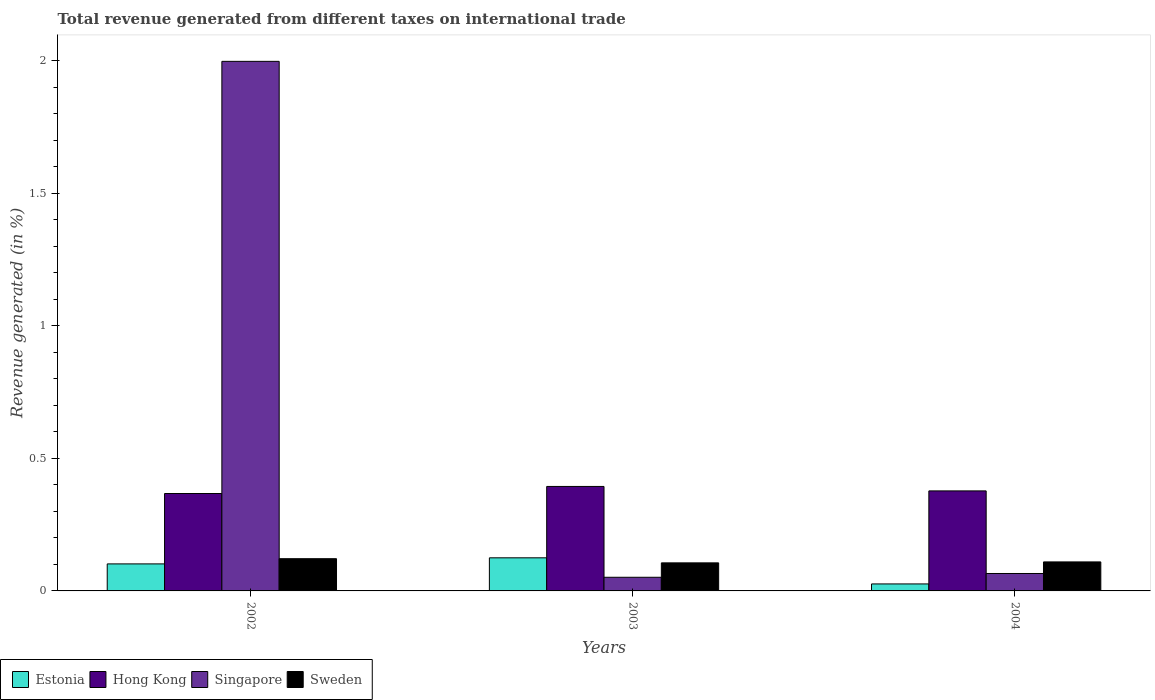How many different coloured bars are there?
Your answer should be compact. 4. How many groups of bars are there?
Your answer should be very brief. 3. Are the number of bars per tick equal to the number of legend labels?
Make the answer very short. Yes. Are the number of bars on each tick of the X-axis equal?
Ensure brevity in your answer.  Yes. How many bars are there on the 2nd tick from the left?
Your response must be concise. 4. What is the label of the 1st group of bars from the left?
Give a very brief answer. 2002. What is the total revenue generated in Singapore in 2004?
Keep it short and to the point. 0.07. Across all years, what is the maximum total revenue generated in Hong Kong?
Keep it short and to the point. 0.39. Across all years, what is the minimum total revenue generated in Singapore?
Make the answer very short. 0.05. In which year was the total revenue generated in Hong Kong maximum?
Your answer should be very brief. 2003. In which year was the total revenue generated in Hong Kong minimum?
Your answer should be very brief. 2002. What is the total total revenue generated in Sweden in the graph?
Offer a terse response. 0.34. What is the difference between the total revenue generated in Hong Kong in 2003 and that in 2004?
Provide a short and direct response. 0.02. What is the difference between the total revenue generated in Sweden in 2002 and the total revenue generated in Estonia in 2004?
Give a very brief answer. 0.1. What is the average total revenue generated in Singapore per year?
Your answer should be very brief. 0.7. In the year 2002, what is the difference between the total revenue generated in Estonia and total revenue generated in Singapore?
Your answer should be very brief. -1.9. In how many years, is the total revenue generated in Hong Kong greater than 1.6 %?
Keep it short and to the point. 0. What is the ratio of the total revenue generated in Estonia in 2002 to that in 2004?
Your response must be concise. 3.87. Is the total revenue generated in Singapore in 2003 less than that in 2004?
Give a very brief answer. Yes. What is the difference between the highest and the second highest total revenue generated in Estonia?
Provide a short and direct response. 0.02. What is the difference between the highest and the lowest total revenue generated in Estonia?
Offer a terse response. 0.1. In how many years, is the total revenue generated in Estonia greater than the average total revenue generated in Estonia taken over all years?
Give a very brief answer. 2. What does the 2nd bar from the left in 2003 represents?
Offer a very short reply. Hong Kong. Is it the case that in every year, the sum of the total revenue generated in Estonia and total revenue generated in Singapore is greater than the total revenue generated in Sweden?
Your response must be concise. No. What is the difference between two consecutive major ticks on the Y-axis?
Offer a very short reply. 0.5. Are the values on the major ticks of Y-axis written in scientific E-notation?
Keep it short and to the point. No. What is the title of the graph?
Keep it short and to the point. Total revenue generated from different taxes on international trade. What is the label or title of the Y-axis?
Offer a very short reply. Revenue generated (in %). What is the Revenue generated (in %) of Estonia in 2002?
Make the answer very short. 0.1. What is the Revenue generated (in %) of Hong Kong in 2002?
Make the answer very short. 0.37. What is the Revenue generated (in %) in Singapore in 2002?
Offer a terse response. 2. What is the Revenue generated (in %) of Sweden in 2002?
Your answer should be compact. 0.12. What is the Revenue generated (in %) in Estonia in 2003?
Offer a very short reply. 0.12. What is the Revenue generated (in %) in Hong Kong in 2003?
Keep it short and to the point. 0.39. What is the Revenue generated (in %) in Singapore in 2003?
Offer a very short reply. 0.05. What is the Revenue generated (in %) of Sweden in 2003?
Keep it short and to the point. 0.11. What is the Revenue generated (in %) in Estonia in 2004?
Provide a succinct answer. 0.03. What is the Revenue generated (in %) of Hong Kong in 2004?
Your answer should be very brief. 0.38. What is the Revenue generated (in %) in Singapore in 2004?
Your answer should be compact. 0.07. What is the Revenue generated (in %) of Sweden in 2004?
Give a very brief answer. 0.11. Across all years, what is the maximum Revenue generated (in %) in Estonia?
Keep it short and to the point. 0.12. Across all years, what is the maximum Revenue generated (in %) of Hong Kong?
Your response must be concise. 0.39. Across all years, what is the maximum Revenue generated (in %) of Singapore?
Provide a succinct answer. 2. Across all years, what is the maximum Revenue generated (in %) in Sweden?
Provide a short and direct response. 0.12. Across all years, what is the minimum Revenue generated (in %) of Estonia?
Your answer should be very brief. 0.03. Across all years, what is the minimum Revenue generated (in %) of Hong Kong?
Your response must be concise. 0.37. Across all years, what is the minimum Revenue generated (in %) in Singapore?
Give a very brief answer. 0.05. Across all years, what is the minimum Revenue generated (in %) of Sweden?
Provide a short and direct response. 0.11. What is the total Revenue generated (in %) in Estonia in the graph?
Your response must be concise. 0.25. What is the total Revenue generated (in %) of Hong Kong in the graph?
Your answer should be very brief. 1.14. What is the total Revenue generated (in %) of Singapore in the graph?
Offer a terse response. 2.11. What is the total Revenue generated (in %) in Sweden in the graph?
Provide a short and direct response. 0.34. What is the difference between the Revenue generated (in %) in Estonia in 2002 and that in 2003?
Give a very brief answer. -0.02. What is the difference between the Revenue generated (in %) in Hong Kong in 2002 and that in 2003?
Your answer should be compact. -0.03. What is the difference between the Revenue generated (in %) in Singapore in 2002 and that in 2003?
Your answer should be compact. 1.95. What is the difference between the Revenue generated (in %) of Sweden in 2002 and that in 2003?
Provide a succinct answer. 0.02. What is the difference between the Revenue generated (in %) of Estonia in 2002 and that in 2004?
Provide a succinct answer. 0.08. What is the difference between the Revenue generated (in %) of Hong Kong in 2002 and that in 2004?
Your answer should be compact. -0.01. What is the difference between the Revenue generated (in %) of Singapore in 2002 and that in 2004?
Offer a terse response. 1.93. What is the difference between the Revenue generated (in %) of Sweden in 2002 and that in 2004?
Give a very brief answer. 0.01. What is the difference between the Revenue generated (in %) of Estonia in 2003 and that in 2004?
Provide a short and direct response. 0.1. What is the difference between the Revenue generated (in %) in Hong Kong in 2003 and that in 2004?
Keep it short and to the point. 0.02. What is the difference between the Revenue generated (in %) of Singapore in 2003 and that in 2004?
Provide a succinct answer. -0.01. What is the difference between the Revenue generated (in %) of Sweden in 2003 and that in 2004?
Give a very brief answer. -0. What is the difference between the Revenue generated (in %) in Estonia in 2002 and the Revenue generated (in %) in Hong Kong in 2003?
Your response must be concise. -0.29. What is the difference between the Revenue generated (in %) in Estonia in 2002 and the Revenue generated (in %) in Singapore in 2003?
Provide a succinct answer. 0.05. What is the difference between the Revenue generated (in %) in Estonia in 2002 and the Revenue generated (in %) in Sweden in 2003?
Provide a short and direct response. -0. What is the difference between the Revenue generated (in %) in Hong Kong in 2002 and the Revenue generated (in %) in Singapore in 2003?
Your answer should be compact. 0.32. What is the difference between the Revenue generated (in %) of Hong Kong in 2002 and the Revenue generated (in %) of Sweden in 2003?
Ensure brevity in your answer.  0.26. What is the difference between the Revenue generated (in %) of Singapore in 2002 and the Revenue generated (in %) of Sweden in 2003?
Offer a very short reply. 1.89. What is the difference between the Revenue generated (in %) of Estonia in 2002 and the Revenue generated (in %) of Hong Kong in 2004?
Offer a terse response. -0.28. What is the difference between the Revenue generated (in %) in Estonia in 2002 and the Revenue generated (in %) in Singapore in 2004?
Provide a short and direct response. 0.04. What is the difference between the Revenue generated (in %) of Estonia in 2002 and the Revenue generated (in %) of Sweden in 2004?
Make the answer very short. -0.01. What is the difference between the Revenue generated (in %) of Hong Kong in 2002 and the Revenue generated (in %) of Singapore in 2004?
Provide a short and direct response. 0.3. What is the difference between the Revenue generated (in %) of Hong Kong in 2002 and the Revenue generated (in %) of Sweden in 2004?
Ensure brevity in your answer.  0.26. What is the difference between the Revenue generated (in %) in Singapore in 2002 and the Revenue generated (in %) in Sweden in 2004?
Keep it short and to the point. 1.89. What is the difference between the Revenue generated (in %) of Estonia in 2003 and the Revenue generated (in %) of Hong Kong in 2004?
Provide a succinct answer. -0.25. What is the difference between the Revenue generated (in %) in Estonia in 2003 and the Revenue generated (in %) in Singapore in 2004?
Your answer should be very brief. 0.06. What is the difference between the Revenue generated (in %) in Estonia in 2003 and the Revenue generated (in %) in Sweden in 2004?
Offer a very short reply. 0.02. What is the difference between the Revenue generated (in %) in Hong Kong in 2003 and the Revenue generated (in %) in Singapore in 2004?
Keep it short and to the point. 0.33. What is the difference between the Revenue generated (in %) in Hong Kong in 2003 and the Revenue generated (in %) in Sweden in 2004?
Offer a terse response. 0.28. What is the difference between the Revenue generated (in %) in Singapore in 2003 and the Revenue generated (in %) in Sweden in 2004?
Ensure brevity in your answer.  -0.06. What is the average Revenue generated (in %) in Estonia per year?
Provide a succinct answer. 0.08. What is the average Revenue generated (in %) in Hong Kong per year?
Ensure brevity in your answer.  0.38. What is the average Revenue generated (in %) of Singapore per year?
Offer a very short reply. 0.7. What is the average Revenue generated (in %) of Sweden per year?
Provide a succinct answer. 0.11. In the year 2002, what is the difference between the Revenue generated (in %) in Estonia and Revenue generated (in %) in Hong Kong?
Your response must be concise. -0.27. In the year 2002, what is the difference between the Revenue generated (in %) of Estonia and Revenue generated (in %) of Singapore?
Provide a short and direct response. -1.9. In the year 2002, what is the difference between the Revenue generated (in %) of Estonia and Revenue generated (in %) of Sweden?
Keep it short and to the point. -0.02. In the year 2002, what is the difference between the Revenue generated (in %) of Hong Kong and Revenue generated (in %) of Singapore?
Keep it short and to the point. -1.63. In the year 2002, what is the difference between the Revenue generated (in %) in Hong Kong and Revenue generated (in %) in Sweden?
Provide a short and direct response. 0.25. In the year 2002, what is the difference between the Revenue generated (in %) of Singapore and Revenue generated (in %) of Sweden?
Provide a short and direct response. 1.88. In the year 2003, what is the difference between the Revenue generated (in %) of Estonia and Revenue generated (in %) of Hong Kong?
Make the answer very short. -0.27. In the year 2003, what is the difference between the Revenue generated (in %) in Estonia and Revenue generated (in %) in Singapore?
Your response must be concise. 0.07. In the year 2003, what is the difference between the Revenue generated (in %) of Estonia and Revenue generated (in %) of Sweden?
Keep it short and to the point. 0.02. In the year 2003, what is the difference between the Revenue generated (in %) of Hong Kong and Revenue generated (in %) of Singapore?
Give a very brief answer. 0.34. In the year 2003, what is the difference between the Revenue generated (in %) in Hong Kong and Revenue generated (in %) in Sweden?
Make the answer very short. 0.29. In the year 2003, what is the difference between the Revenue generated (in %) of Singapore and Revenue generated (in %) of Sweden?
Offer a very short reply. -0.05. In the year 2004, what is the difference between the Revenue generated (in %) of Estonia and Revenue generated (in %) of Hong Kong?
Your answer should be very brief. -0.35. In the year 2004, what is the difference between the Revenue generated (in %) in Estonia and Revenue generated (in %) in Singapore?
Your answer should be very brief. -0.04. In the year 2004, what is the difference between the Revenue generated (in %) in Estonia and Revenue generated (in %) in Sweden?
Your response must be concise. -0.08. In the year 2004, what is the difference between the Revenue generated (in %) in Hong Kong and Revenue generated (in %) in Singapore?
Offer a very short reply. 0.31. In the year 2004, what is the difference between the Revenue generated (in %) in Hong Kong and Revenue generated (in %) in Sweden?
Give a very brief answer. 0.27. In the year 2004, what is the difference between the Revenue generated (in %) in Singapore and Revenue generated (in %) in Sweden?
Ensure brevity in your answer.  -0.04. What is the ratio of the Revenue generated (in %) in Estonia in 2002 to that in 2003?
Your answer should be compact. 0.82. What is the ratio of the Revenue generated (in %) of Hong Kong in 2002 to that in 2003?
Give a very brief answer. 0.93. What is the ratio of the Revenue generated (in %) of Singapore in 2002 to that in 2003?
Keep it short and to the point. 38.82. What is the ratio of the Revenue generated (in %) of Sweden in 2002 to that in 2003?
Offer a very short reply. 1.15. What is the ratio of the Revenue generated (in %) in Estonia in 2002 to that in 2004?
Offer a terse response. 3.87. What is the ratio of the Revenue generated (in %) in Hong Kong in 2002 to that in 2004?
Make the answer very short. 0.97. What is the ratio of the Revenue generated (in %) in Singapore in 2002 to that in 2004?
Offer a terse response. 30.39. What is the ratio of the Revenue generated (in %) in Sweden in 2002 to that in 2004?
Your answer should be compact. 1.11. What is the ratio of the Revenue generated (in %) of Estonia in 2003 to that in 2004?
Your answer should be compact. 4.74. What is the ratio of the Revenue generated (in %) in Hong Kong in 2003 to that in 2004?
Offer a terse response. 1.04. What is the ratio of the Revenue generated (in %) in Singapore in 2003 to that in 2004?
Provide a succinct answer. 0.78. What is the difference between the highest and the second highest Revenue generated (in %) of Estonia?
Ensure brevity in your answer.  0.02. What is the difference between the highest and the second highest Revenue generated (in %) in Hong Kong?
Give a very brief answer. 0.02. What is the difference between the highest and the second highest Revenue generated (in %) in Singapore?
Keep it short and to the point. 1.93. What is the difference between the highest and the second highest Revenue generated (in %) in Sweden?
Provide a short and direct response. 0.01. What is the difference between the highest and the lowest Revenue generated (in %) of Estonia?
Your answer should be compact. 0.1. What is the difference between the highest and the lowest Revenue generated (in %) in Hong Kong?
Give a very brief answer. 0.03. What is the difference between the highest and the lowest Revenue generated (in %) of Singapore?
Your answer should be very brief. 1.95. What is the difference between the highest and the lowest Revenue generated (in %) of Sweden?
Your answer should be compact. 0.02. 